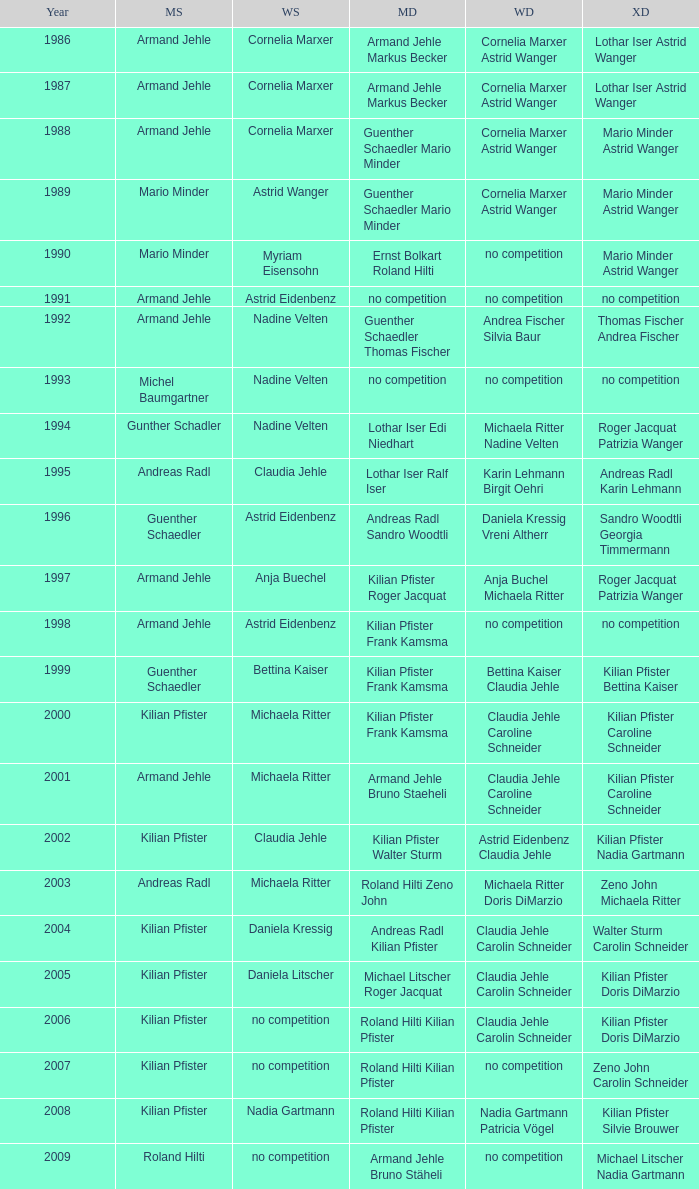In 2001, where the mens singles is armand jehle and the womens singles is michaela ritter, who are the mixed doubles Kilian Pfister Caroline Schneider. 